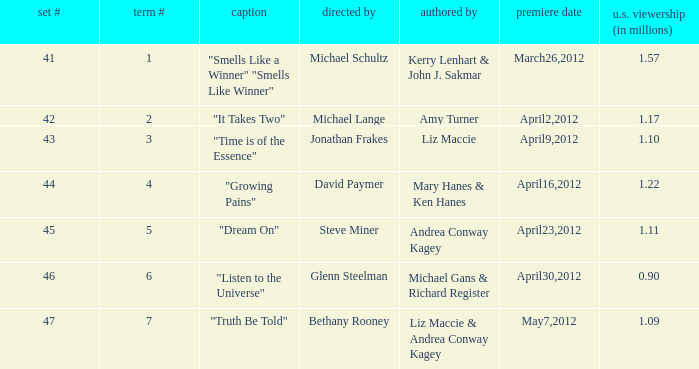What are the titles of the episodes which had 1.10 million U.S. viewers? "Time is of the Essence". 